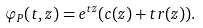<formula> <loc_0><loc_0><loc_500><loc_500>\varphi _ { P } ( t , z ) = e ^ { t z } ( c ( z ) + t r ( z ) ) .</formula> 